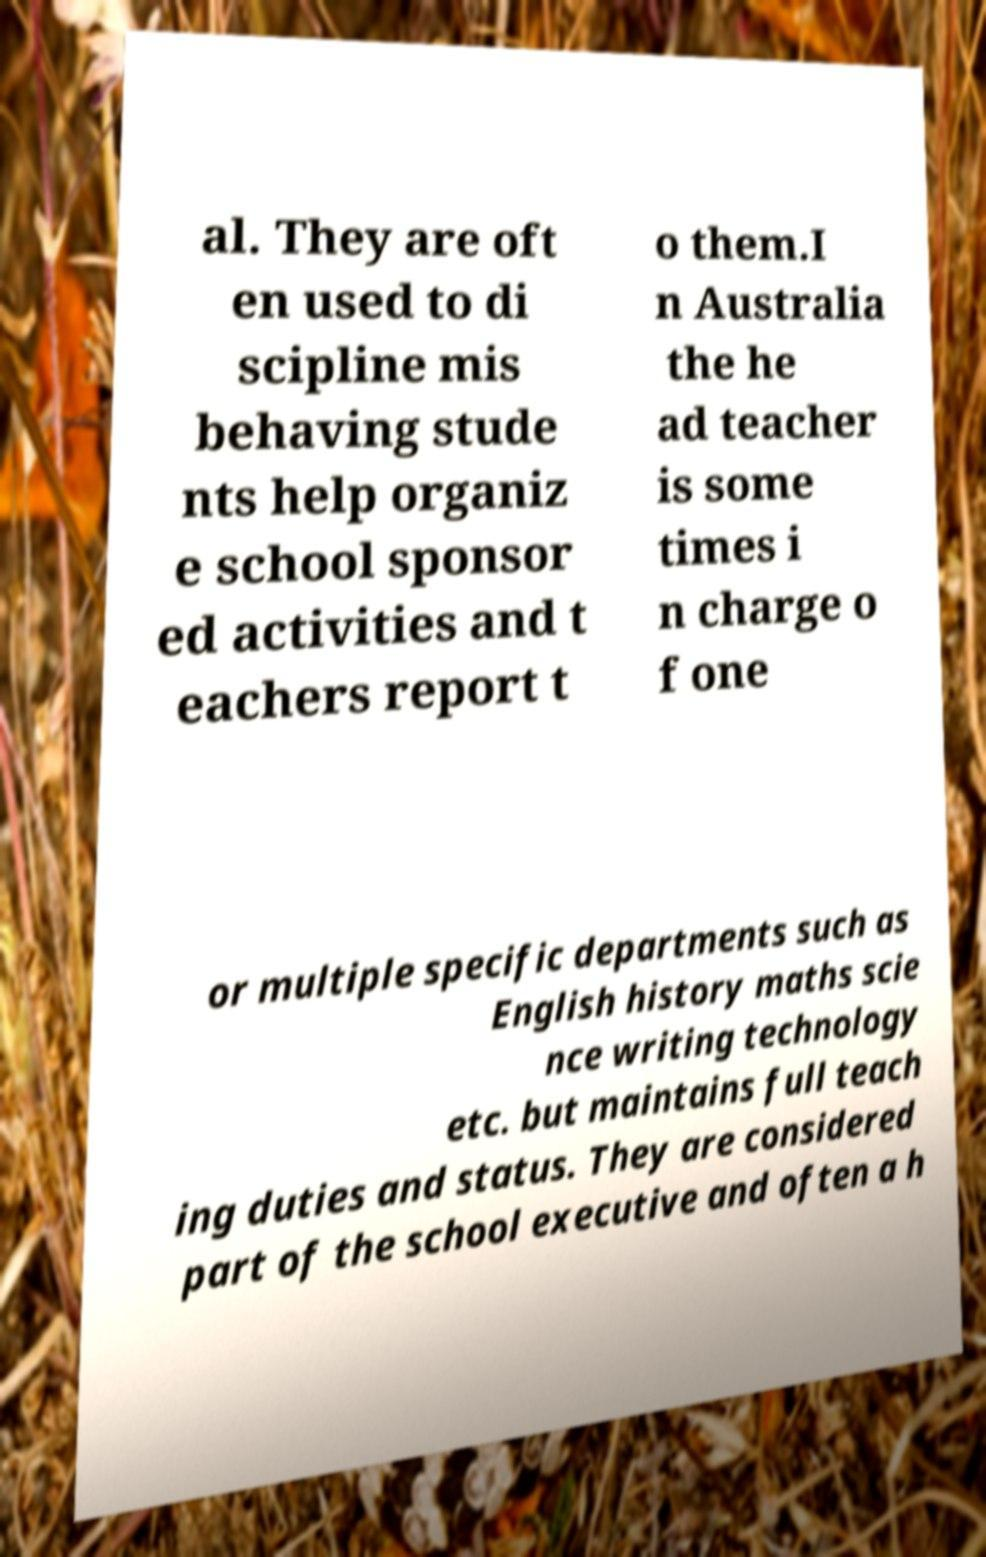I need the written content from this picture converted into text. Can you do that? al. They are oft en used to di scipline mis behaving stude nts help organiz e school sponsor ed activities and t eachers report t o them.I n Australia the he ad teacher is some times i n charge o f one or multiple specific departments such as English history maths scie nce writing technology etc. but maintains full teach ing duties and status. They are considered part of the school executive and often a h 